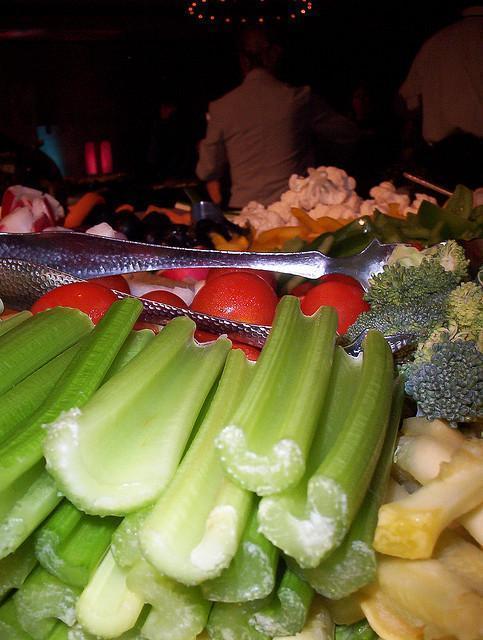What type of silver utensil sits atop the salad bar?
Select the accurate answer and provide justification: `Answer: choice
Rationale: srationale.`
Options: Spoon, tongs, knife, fork. Answer: tongs.
Rationale: The silver utensils are tongs. 